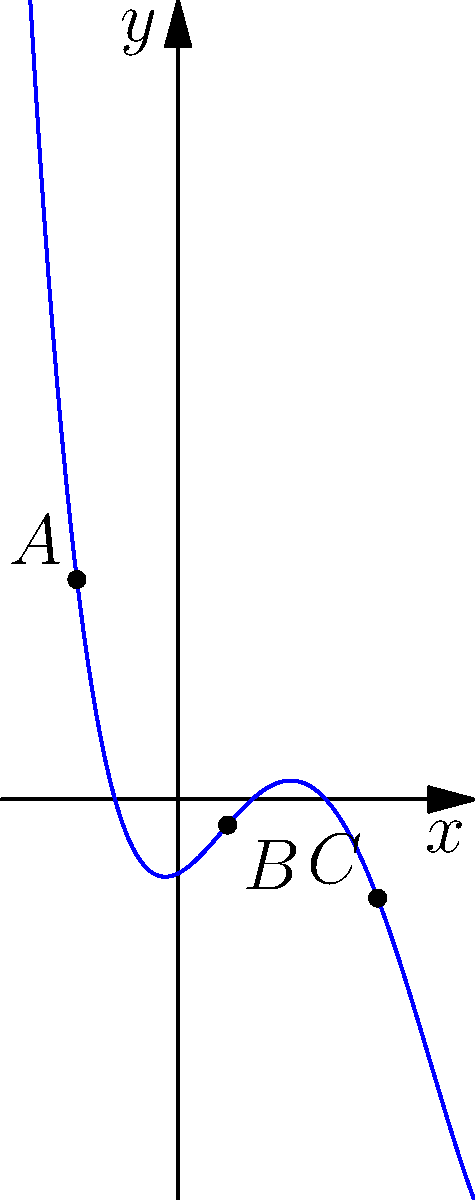Consider the polynomial graph above, which represents a function $f(x)$. Points $A$, $B$, and $C$ are critical points of the function. Determine the intervals where the function is increasing and decreasing. How might this analysis relate to Dr. Anthony Neal's perspective on the ebb and flow of social progress in African American history? To determine the intervals of increase and decrease, we'll follow these steps:

1) Identify the x-coordinates of the critical points:
   A: $x \approx -1.37$
   B: $x \approx 0.67$
   C: $x \approx 2.70$

2) Divide the x-axis into intervals based on these points:
   $(-\infty, -1.37)$, $(-1.37, 0.67)$, $(0.67, 2.70)$, $(2.70, \infty)$

3) Analyze the behavior of the function in each interval:

   $(-\infty, -1.37)$: The graph is rising, so the function is increasing.
   $(-1.37, 0.67)$: The graph is falling, so the function is decreasing.
   $(0.67, 2.70)$: The graph is rising, so the function is increasing.
   $(2.70, \infty)$: The graph is rising, so the function is increasing.

4) Combine adjacent intervals with the same behavior:

   Increasing: $(-\infty, -1.37)$ and $(0.67, \infty)$
   Decreasing: $(-1.37, 0.67)$

Relating to Dr. Anthony Neal's perspective:
This analysis mirrors Dr. Neal's view on the non-linear nature of social progress in African American history. The intervals of increase could represent periods of advancement and empowerment, while the interval of decrease might symbolize times of setback or struggle. Just as the function eventually trends upward, Dr. Neal often emphasizes the overall positive trajectory of progress, despite temporary setbacks.
Answer: Increasing: $(-\infty, -1.37)$ and $(0.67, \infty)$; Decreasing: $(-1.37, 0.67)$ 